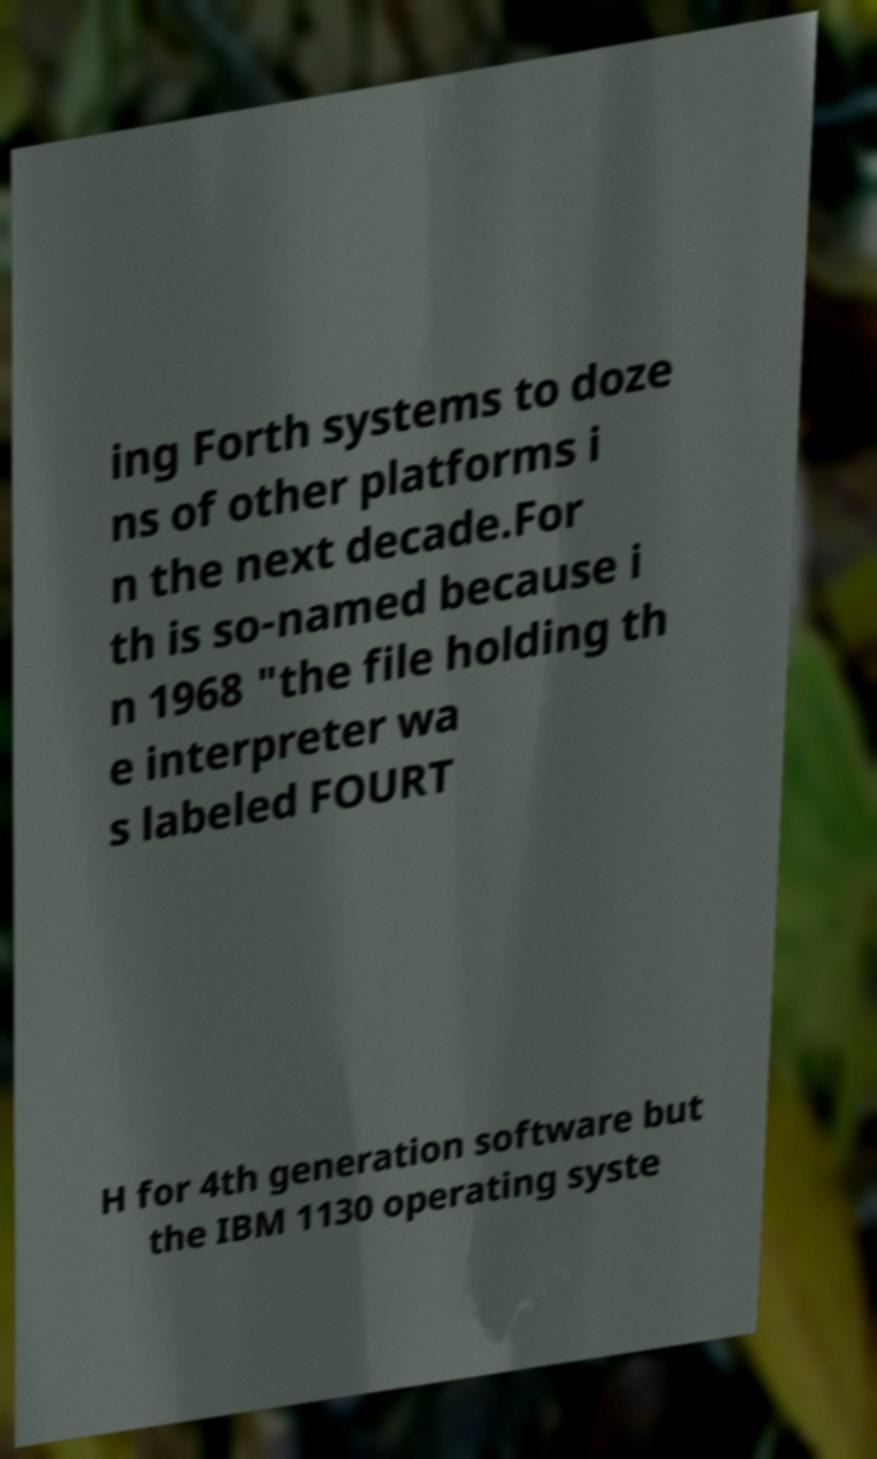For documentation purposes, I need the text within this image transcribed. Could you provide that? ing Forth systems to doze ns of other platforms i n the next decade.For th is so-named because i n 1968 "the file holding th e interpreter wa s labeled FOURT H for 4th generation software but the IBM 1130 operating syste 